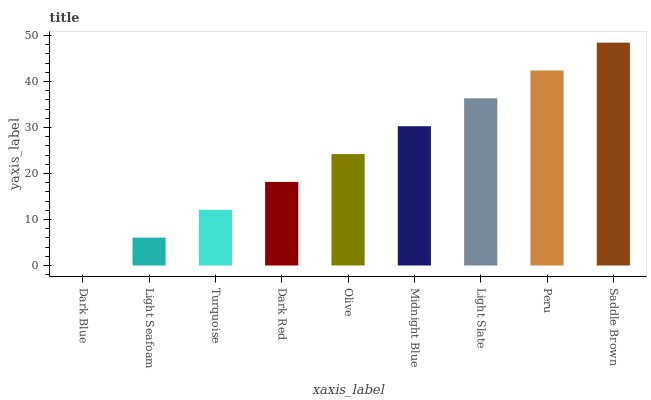Is Dark Blue the minimum?
Answer yes or no. Yes. Is Saddle Brown the maximum?
Answer yes or no. Yes. Is Light Seafoam the minimum?
Answer yes or no. No. Is Light Seafoam the maximum?
Answer yes or no. No. Is Light Seafoam greater than Dark Blue?
Answer yes or no. Yes. Is Dark Blue less than Light Seafoam?
Answer yes or no. Yes. Is Dark Blue greater than Light Seafoam?
Answer yes or no. No. Is Light Seafoam less than Dark Blue?
Answer yes or no. No. Is Olive the high median?
Answer yes or no. Yes. Is Olive the low median?
Answer yes or no. Yes. Is Midnight Blue the high median?
Answer yes or no. No. Is Light Slate the low median?
Answer yes or no. No. 